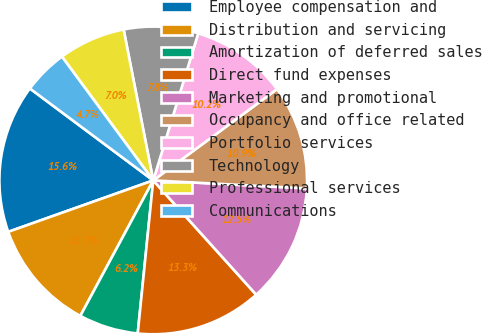<chart> <loc_0><loc_0><loc_500><loc_500><pie_chart><fcel>Employee compensation and<fcel>Distribution and servicing<fcel>Amortization of deferred sales<fcel>Direct fund expenses<fcel>Marketing and promotional<fcel>Occupancy and office related<fcel>Portfolio services<fcel>Technology<fcel>Professional services<fcel>Communications<nl><fcel>15.62%<fcel>11.72%<fcel>6.25%<fcel>13.28%<fcel>12.5%<fcel>10.94%<fcel>10.16%<fcel>7.81%<fcel>7.03%<fcel>4.69%<nl></chart> 